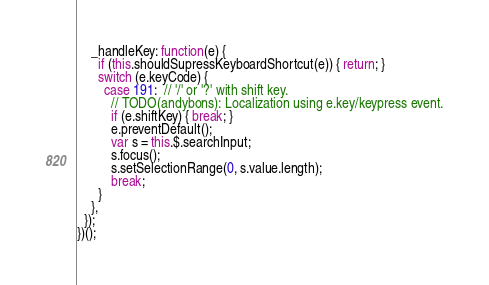Convert code to text. <code><loc_0><loc_0><loc_500><loc_500><_JavaScript_>    _handleKey: function(e) {
      if (this.shouldSupressKeyboardShortcut(e)) { return; }
      switch (e.keyCode) {
        case 191:  // '/' or '?' with shift key.
          // TODO(andybons): Localization using e.key/keypress event.
          if (e.shiftKey) { break; }
          e.preventDefault();
          var s = this.$.searchInput;
          s.focus();
          s.setSelectionRange(0, s.value.length);
          break;
      }
    },
  });
})();
</code> 